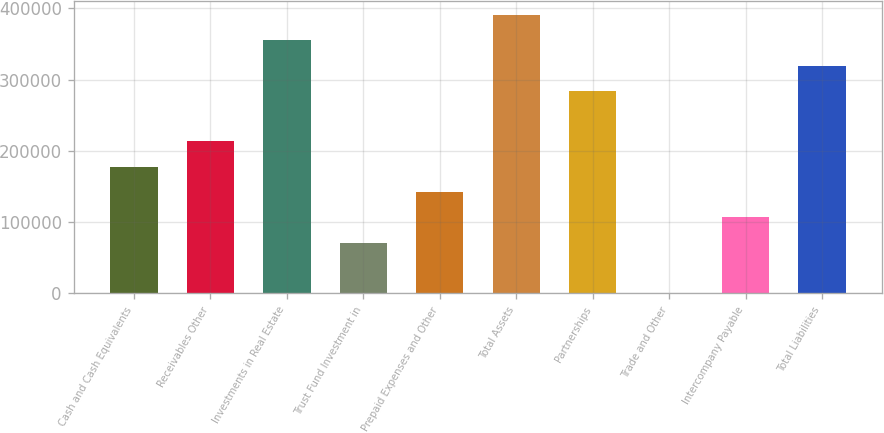Convert chart to OTSL. <chart><loc_0><loc_0><loc_500><loc_500><bar_chart><fcel>Cash and Cash Equivalents<fcel>Receivables Other<fcel>Investments in Real Estate<fcel>Trust Fund Investment in<fcel>Prepaid Expenses and Other<fcel>Total Assets<fcel>Partnerships<fcel>Trade and Other<fcel>Intercompany Payable<fcel>Total Liabilities<nl><fcel>177768<fcel>213265<fcel>355256<fcel>71274.4<fcel>142270<fcel>390754<fcel>284261<fcel>279<fcel>106772<fcel>319758<nl></chart> 